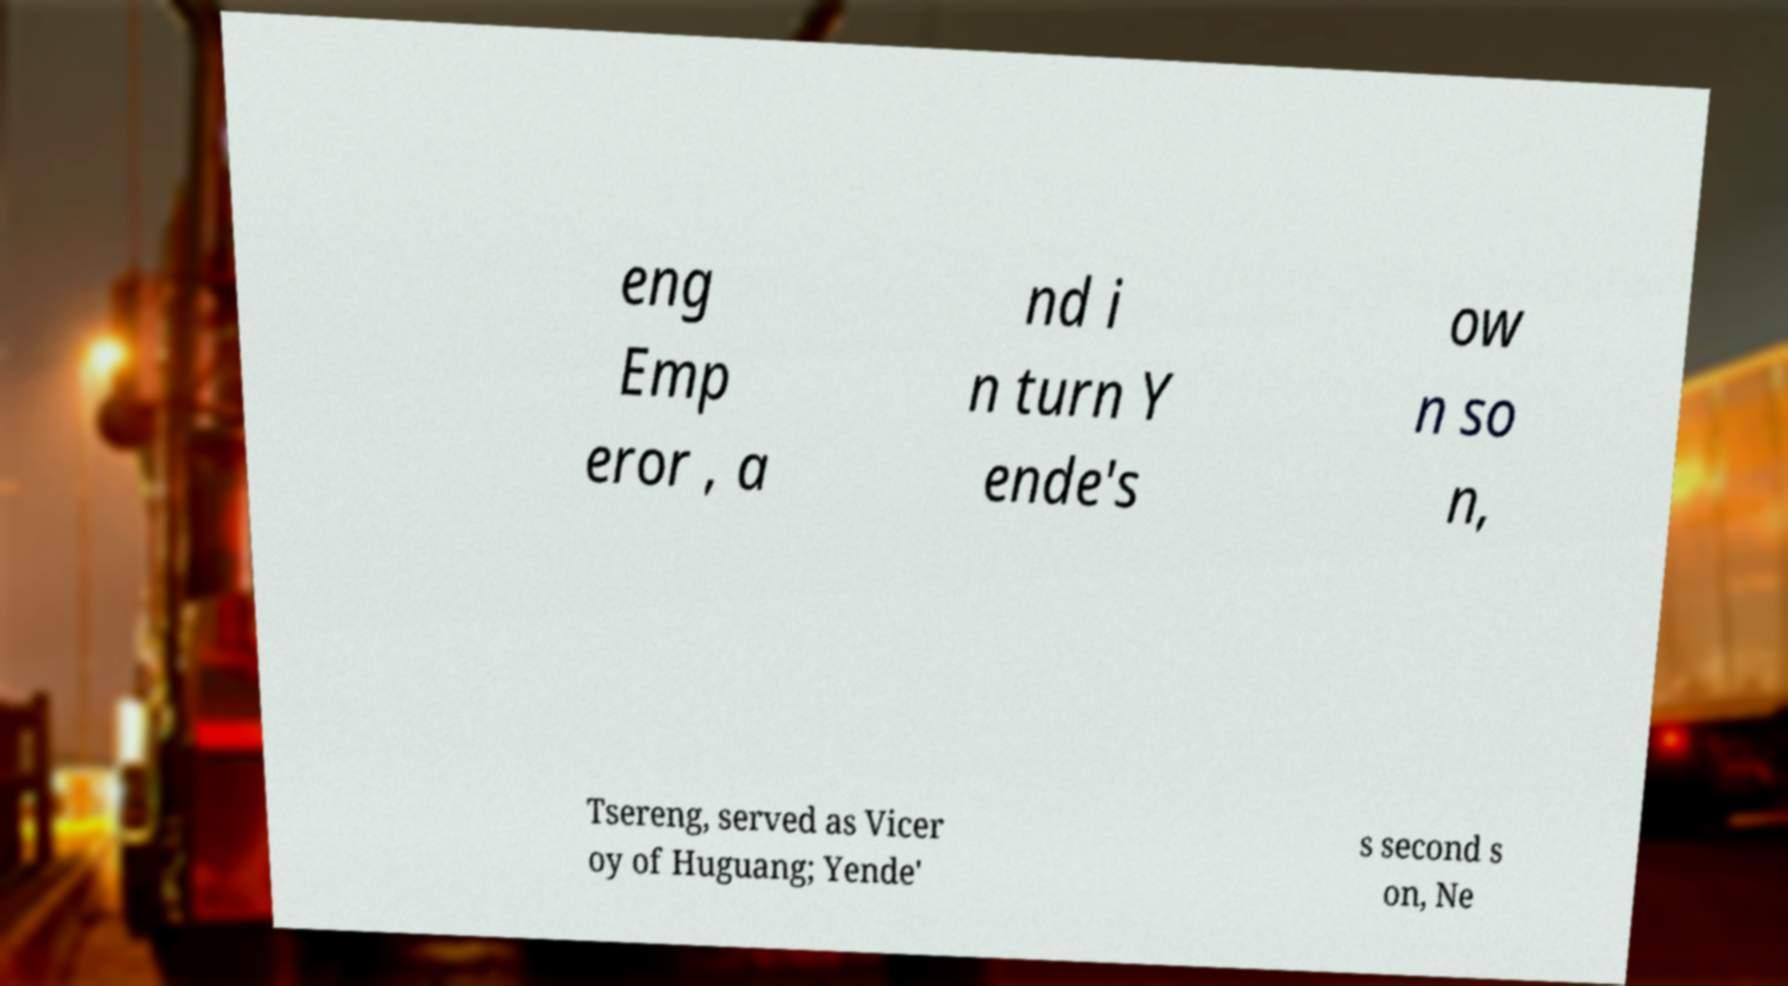Can you read and provide the text displayed in the image?This photo seems to have some interesting text. Can you extract and type it out for me? eng Emp eror , a nd i n turn Y ende's ow n so n, Tsereng, served as Vicer oy of Huguang; Yende' s second s on, Ne 